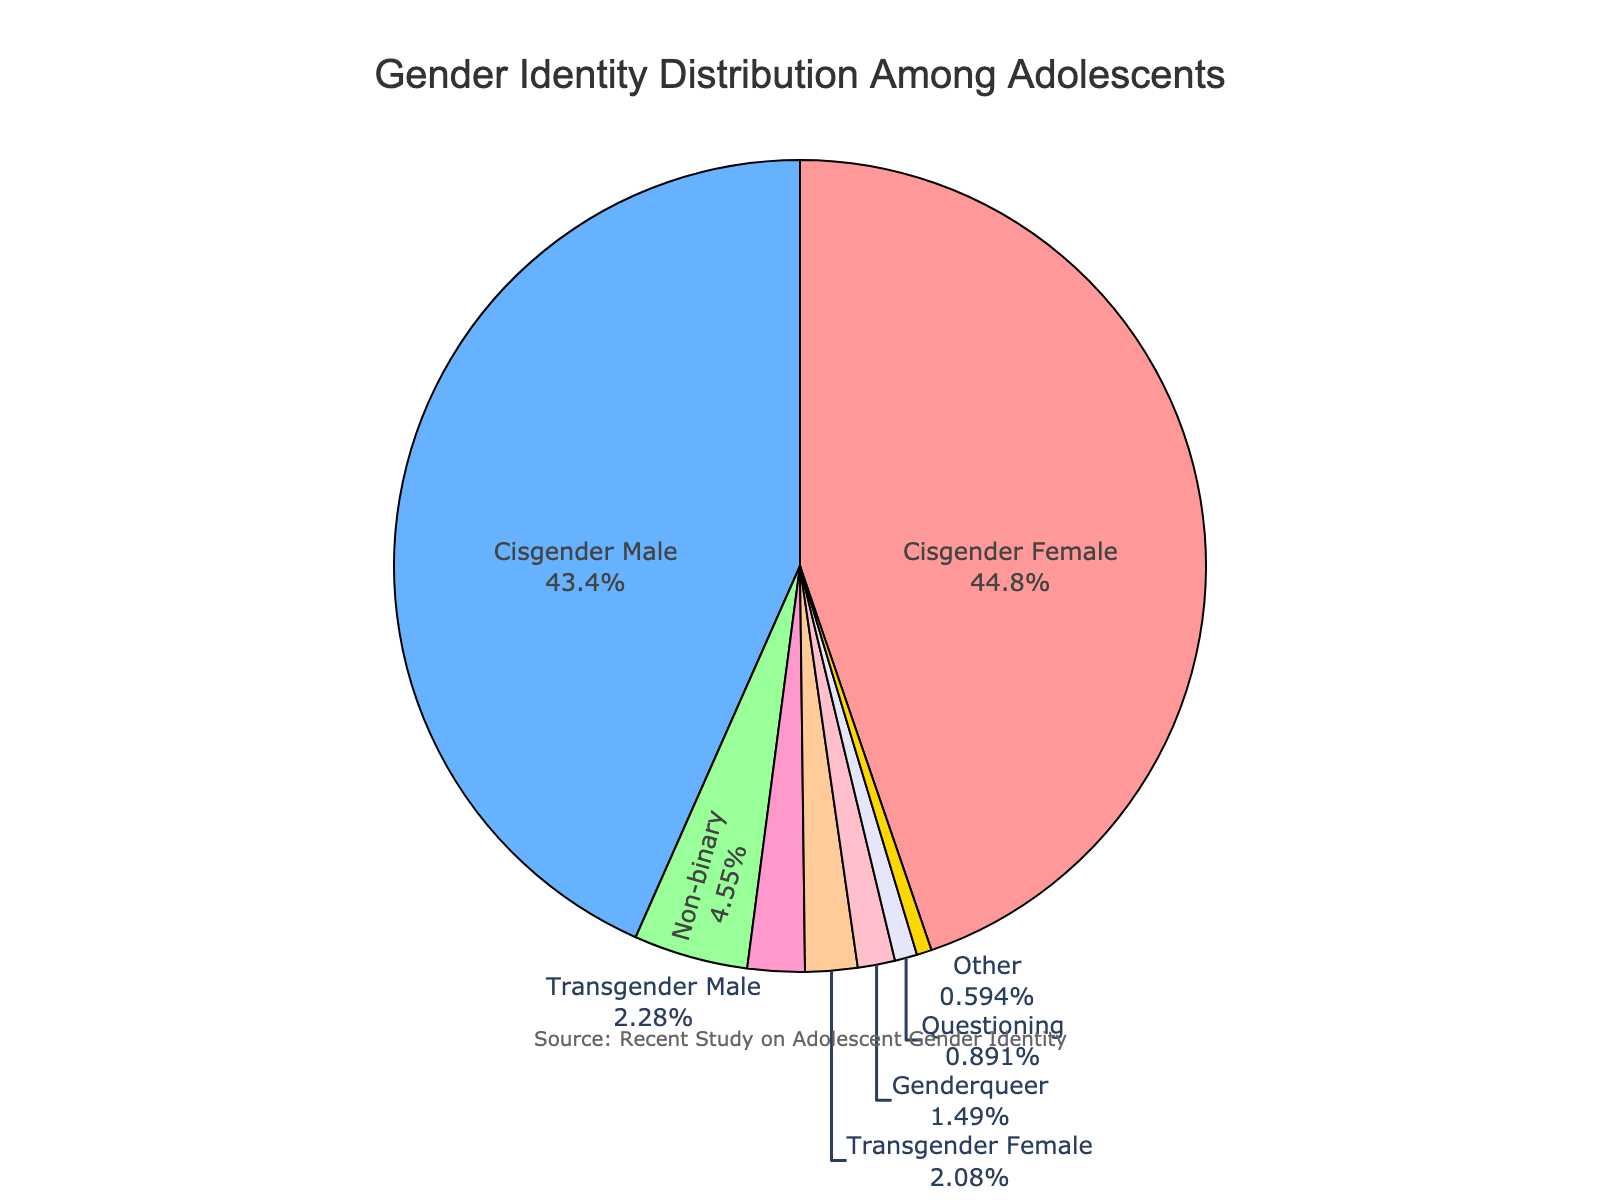What is the combined percentage of adolescents identifying as Transgender Female and Transgender Male? To find the combined percentage, add the percentage of Transgender Female (2.1%) and Transgender Male (2.3%). The sum is 2.1 + 2.3 = 4.4%.
Answer: 4.4% Which gender identity has the largest representation among adolescents? Look at the pie chart and find the segment with the largest size. The segment labeled "Cisgender Female" is the largest.
Answer: Cisgender Female How much greater is the percentage of Cisgender Females compared to Non-binary individuals? Subtract the percentage of Non-binary individuals (4.6%) from the percentage of Cisgender Females (45.2%). The difference is 45.2 - 4.6 = 40.6%.
Answer: 40.6% Which gender identities together make up less than 5% of the population? Look at the segments with percentages less than 5%. These are Non-binary (4.6%), Transgender Female (2.1%), Transgender Male (2.3%), Genderqueer (1.5%), Questioning (0.9%), and Other (0.6%).
Answer: Non-binary, Transgender Female, Transgender Male, Genderqueer, Questioning, Other What is the smallest group represented in the chart, and what is their percentage? Identify the smallest segment in the pie chart. The segment labeled "Other" is the smallest with a percentage of 0.6%.
Answer: Other, 0.6% How does the percentage of Cisgender Males compare to that of Cisgender Females? Examine the percentages for Cisgender Males (43.8%) and Cisgender Females (45.2%). Cisgender Females have a higher percentage than Cisgender Males.
Answer: Cisgender Females have a higher percentage If you combine the percentages of Genderqueer and Questioning individuals, is their total greater than the percentage of Non-binary individuals? Add the percentages of Genderqueer (1.5%) and Questioning (0.9%), which sums to 1.5 + 0.9 = 2.4%. This is less than the percentage of Non-binary individuals (4.6%).
Answer: No, 2.4% is less than 4.6% What is the total percentage of adolescents identifying as either Genderqueer or Other? Add the percentages of Genderqueer (1.5%) and Other (0.6%). The sum is 1.5 + 0.6 = 2.1%.
Answer: 2.1% Is the combined percentage of all groups besides Cisgender Male and Cisgender Female higher or lower than the percentage of Cisgender Females? Add the percentages of all groups besides Cisgender Male (43.8%) and Cisgender Female (45.2%): Non-binary (4.6%), Transgender Female (2.1%), Transgender Male (2.3%), Genderqueer (1.5%), Questioning (0.9%), and Other (0.6%), which sums to 4.6 + 2.1 + 2.3 + 1.5 + 0.9 + 0.6 = 12%. This is lower than the percentage of Cisgender Females (45.2%).
Answer: Lower What is the total percentage represented by Cisgender Male and Cisgender Female combined? Add the percentages of Cisgender Male (43.8%) and Cisgender Female (45.2%). The sum is 43.8 + 45.2 = 89%.
Answer: 89% 